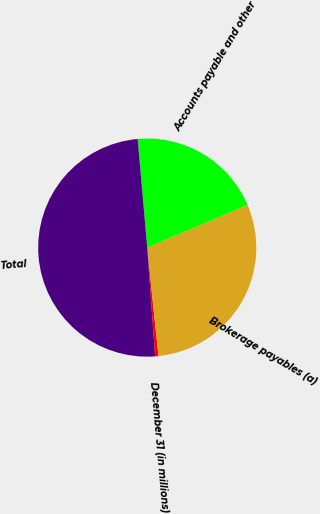<chart> <loc_0><loc_0><loc_500><loc_500><pie_chart><fcel>December 31 (in millions)<fcel>Brokerage payables (a)<fcel>Accounts payable and other<fcel>Total<nl><fcel>0.49%<fcel>29.76%<fcel>20.0%<fcel>49.75%<nl></chart> 